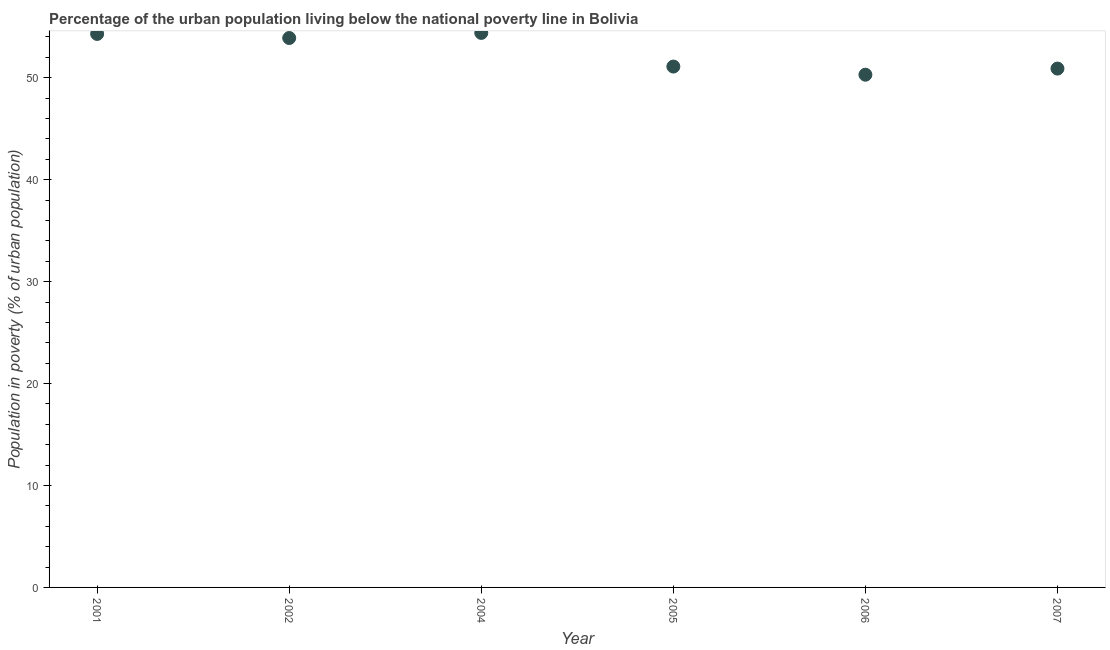What is the percentage of urban population living below poverty line in 2007?
Your response must be concise. 50.9. Across all years, what is the maximum percentage of urban population living below poverty line?
Make the answer very short. 54.4. Across all years, what is the minimum percentage of urban population living below poverty line?
Your response must be concise. 50.3. In which year was the percentage of urban population living below poverty line minimum?
Provide a succinct answer. 2006. What is the sum of the percentage of urban population living below poverty line?
Give a very brief answer. 314.9. What is the difference between the percentage of urban population living below poverty line in 2005 and 2007?
Keep it short and to the point. 0.2. What is the average percentage of urban population living below poverty line per year?
Provide a succinct answer. 52.48. What is the median percentage of urban population living below poverty line?
Give a very brief answer. 52.5. Do a majority of the years between 2006 and 2001 (inclusive) have percentage of urban population living below poverty line greater than 28 %?
Keep it short and to the point. Yes. What is the ratio of the percentage of urban population living below poverty line in 2005 to that in 2006?
Your answer should be very brief. 1.02. What is the difference between the highest and the second highest percentage of urban population living below poverty line?
Give a very brief answer. 0.1. What is the difference between the highest and the lowest percentage of urban population living below poverty line?
Offer a very short reply. 4.1. In how many years, is the percentage of urban population living below poverty line greater than the average percentage of urban population living below poverty line taken over all years?
Ensure brevity in your answer.  3. How many dotlines are there?
Your answer should be very brief. 1. Does the graph contain any zero values?
Your answer should be compact. No. Does the graph contain grids?
Your answer should be very brief. No. What is the title of the graph?
Make the answer very short. Percentage of the urban population living below the national poverty line in Bolivia. What is the label or title of the X-axis?
Your answer should be very brief. Year. What is the label or title of the Y-axis?
Your answer should be compact. Population in poverty (% of urban population). What is the Population in poverty (% of urban population) in 2001?
Provide a short and direct response. 54.3. What is the Population in poverty (% of urban population) in 2002?
Keep it short and to the point. 53.9. What is the Population in poverty (% of urban population) in 2004?
Give a very brief answer. 54.4. What is the Population in poverty (% of urban population) in 2005?
Provide a succinct answer. 51.1. What is the Population in poverty (% of urban population) in 2006?
Ensure brevity in your answer.  50.3. What is the Population in poverty (% of urban population) in 2007?
Provide a succinct answer. 50.9. What is the difference between the Population in poverty (% of urban population) in 2001 and 2002?
Offer a very short reply. 0.4. What is the difference between the Population in poverty (% of urban population) in 2001 and 2004?
Provide a succinct answer. -0.1. What is the difference between the Population in poverty (% of urban population) in 2001 and 2005?
Give a very brief answer. 3.2. What is the difference between the Population in poverty (% of urban population) in 2001 and 2007?
Offer a very short reply. 3.4. What is the difference between the Population in poverty (% of urban population) in 2002 and 2004?
Provide a short and direct response. -0.5. What is the difference between the Population in poverty (% of urban population) in 2002 and 2006?
Give a very brief answer. 3.6. What is the difference between the Population in poverty (% of urban population) in 2004 and 2005?
Make the answer very short. 3.3. What is the ratio of the Population in poverty (% of urban population) in 2001 to that in 2002?
Your response must be concise. 1.01. What is the ratio of the Population in poverty (% of urban population) in 2001 to that in 2004?
Your response must be concise. 1. What is the ratio of the Population in poverty (% of urban population) in 2001 to that in 2005?
Your response must be concise. 1.06. What is the ratio of the Population in poverty (% of urban population) in 2001 to that in 2006?
Offer a terse response. 1.08. What is the ratio of the Population in poverty (% of urban population) in 2001 to that in 2007?
Ensure brevity in your answer.  1.07. What is the ratio of the Population in poverty (% of urban population) in 2002 to that in 2004?
Offer a very short reply. 0.99. What is the ratio of the Population in poverty (% of urban population) in 2002 to that in 2005?
Provide a short and direct response. 1.05. What is the ratio of the Population in poverty (% of urban population) in 2002 to that in 2006?
Provide a succinct answer. 1.07. What is the ratio of the Population in poverty (% of urban population) in 2002 to that in 2007?
Your response must be concise. 1.06. What is the ratio of the Population in poverty (% of urban population) in 2004 to that in 2005?
Ensure brevity in your answer.  1.06. What is the ratio of the Population in poverty (% of urban population) in 2004 to that in 2006?
Keep it short and to the point. 1.08. What is the ratio of the Population in poverty (% of urban population) in 2004 to that in 2007?
Ensure brevity in your answer.  1.07. What is the ratio of the Population in poverty (% of urban population) in 2006 to that in 2007?
Make the answer very short. 0.99. 